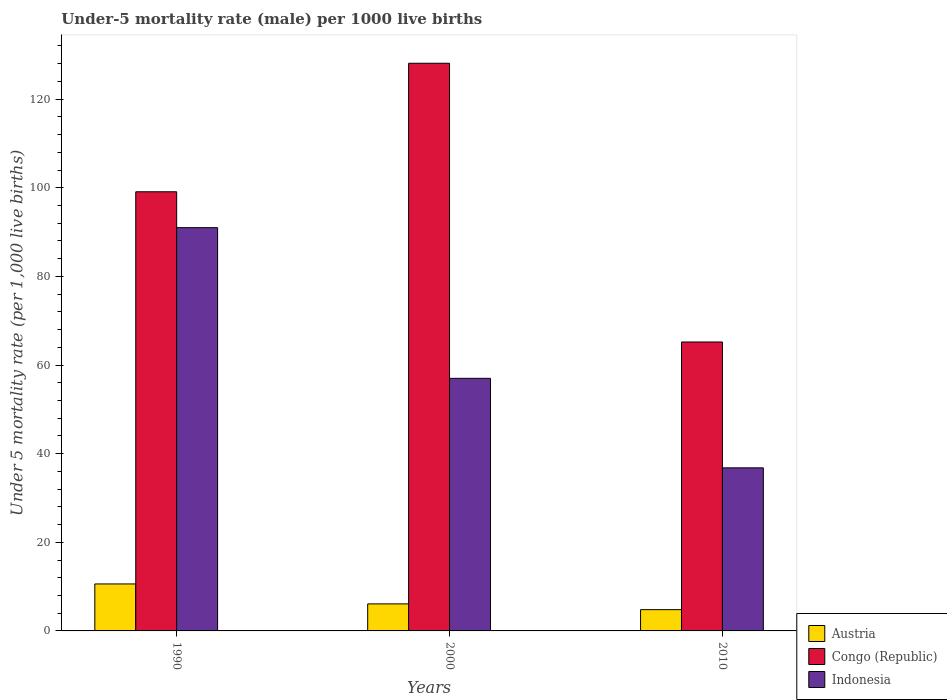How many different coloured bars are there?
Make the answer very short. 3. What is the label of the 3rd group of bars from the left?
Ensure brevity in your answer.  2010. In how many cases, is the number of bars for a given year not equal to the number of legend labels?
Provide a succinct answer. 0. What is the under-five mortality rate in Indonesia in 2010?
Give a very brief answer. 36.8. Across all years, what is the maximum under-five mortality rate in Indonesia?
Ensure brevity in your answer.  91. Across all years, what is the minimum under-five mortality rate in Indonesia?
Provide a succinct answer. 36.8. In which year was the under-five mortality rate in Congo (Republic) maximum?
Provide a short and direct response. 2000. In which year was the under-five mortality rate in Austria minimum?
Provide a succinct answer. 2010. What is the total under-five mortality rate in Congo (Republic) in the graph?
Make the answer very short. 292.4. What is the difference between the under-five mortality rate in Indonesia in 2000 and that in 2010?
Provide a short and direct response. 20.2. What is the difference between the under-five mortality rate in Congo (Republic) in 2010 and the under-five mortality rate in Indonesia in 1990?
Your response must be concise. -25.8. What is the average under-five mortality rate in Austria per year?
Offer a very short reply. 7.17. In the year 2010, what is the difference between the under-five mortality rate in Indonesia and under-five mortality rate in Congo (Republic)?
Give a very brief answer. -28.4. In how many years, is the under-five mortality rate in Indonesia greater than 80?
Ensure brevity in your answer.  1. What is the ratio of the under-five mortality rate in Congo (Republic) in 1990 to that in 2000?
Your response must be concise. 0.77. Is the under-five mortality rate in Austria in 1990 less than that in 2010?
Give a very brief answer. No. What is the difference between the highest and the second highest under-five mortality rate in Congo (Republic)?
Provide a succinct answer. 29. What is the difference between the highest and the lowest under-five mortality rate in Congo (Republic)?
Your response must be concise. 62.9. In how many years, is the under-five mortality rate in Indonesia greater than the average under-five mortality rate in Indonesia taken over all years?
Your response must be concise. 1. What does the 1st bar from the right in 2010 represents?
Provide a short and direct response. Indonesia. Are the values on the major ticks of Y-axis written in scientific E-notation?
Give a very brief answer. No. Does the graph contain grids?
Your answer should be compact. No. Where does the legend appear in the graph?
Provide a short and direct response. Bottom right. What is the title of the graph?
Ensure brevity in your answer.  Under-5 mortality rate (male) per 1000 live births. What is the label or title of the X-axis?
Give a very brief answer. Years. What is the label or title of the Y-axis?
Your answer should be compact. Under 5 mortality rate (per 1,0 live births). What is the Under 5 mortality rate (per 1,000 live births) in Austria in 1990?
Ensure brevity in your answer.  10.6. What is the Under 5 mortality rate (per 1,000 live births) of Congo (Republic) in 1990?
Your response must be concise. 99.1. What is the Under 5 mortality rate (per 1,000 live births) of Indonesia in 1990?
Your answer should be very brief. 91. What is the Under 5 mortality rate (per 1,000 live births) of Austria in 2000?
Provide a succinct answer. 6.1. What is the Under 5 mortality rate (per 1,000 live births) of Congo (Republic) in 2000?
Offer a very short reply. 128.1. What is the Under 5 mortality rate (per 1,000 live births) of Congo (Republic) in 2010?
Offer a terse response. 65.2. What is the Under 5 mortality rate (per 1,000 live births) in Indonesia in 2010?
Keep it short and to the point. 36.8. Across all years, what is the maximum Under 5 mortality rate (per 1,000 live births) in Austria?
Your answer should be compact. 10.6. Across all years, what is the maximum Under 5 mortality rate (per 1,000 live births) of Congo (Republic)?
Ensure brevity in your answer.  128.1. Across all years, what is the maximum Under 5 mortality rate (per 1,000 live births) in Indonesia?
Make the answer very short. 91. Across all years, what is the minimum Under 5 mortality rate (per 1,000 live births) in Austria?
Your answer should be very brief. 4.8. Across all years, what is the minimum Under 5 mortality rate (per 1,000 live births) of Congo (Republic)?
Provide a succinct answer. 65.2. Across all years, what is the minimum Under 5 mortality rate (per 1,000 live births) of Indonesia?
Provide a short and direct response. 36.8. What is the total Under 5 mortality rate (per 1,000 live births) in Congo (Republic) in the graph?
Offer a very short reply. 292.4. What is the total Under 5 mortality rate (per 1,000 live births) in Indonesia in the graph?
Ensure brevity in your answer.  184.8. What is the difference between the Under 5 mortality rate (per 1,000 live births) of Congo (Republic) in 1990 and that in 2010?
Give a very brief answer. 33.9. What is the difference between the Under 5 mortality rate (per 1,000 live births) of Indonesia in 1990 and that in 2010?
Ensure brevity in your answer.  54.2. What is the difference between the Under 5 mortality rate (per 1,000 live births) in Congo (Republic) in 2000 and that in 2010?
Ensure brevity in your answer.  62.9. What is the difference between the Under 5 mortality rate (per 1,000 live births) in Indonesia in 2000 and that in 2010?
Provide a succinct answer. 20.2. What is the difference between the Under 5 mortality rate (per 1,000 live births) of Austria in 1990 and the Under 5 mortality rate (per 1,000 live births) of Congo (Republic) in 2000?
Provide a short and direct response. -117.5. What is the difference between the Under 5 mortality rate (per 1,000 live births) of Austria in 1990 and the Under 5 mortality rate (per 1,000 live births) of Indonesia in 2000?
Keep it short and to the point. -46.4. What is the difference between the Under 5 mortality rate (per 1,000 live births) of Congo (Republic) in 1990 and the Under 5 mortality rate (per 1,000 live births) of Indonesia in 2000?
Give a very brief answer. 42.1. What is the difference between the Under 5 mortality rate (per 1,000 live births) in Austria in 1990 and the Under 5 mortality rate (per 1,000 live births) in Congo (Republic) in 2010?
Make the answer very short. -54.6. What is the difference between the Under 5 mortality rate (per 1,000 live births) in Austria in 1990 and the Under 5 mortality rate (per 1,000 live births) in Indonesia in 2010?
Give a very brief answer. -26.2. What is the difference between the Under 5 mortality rate (per 1,000 live births) in Congo (Republic) in 1990 and the Under 5 mortality rate (per 1,000 live births) in Indonesia in 2010?
Offer a terse response. 62.3. What is the difference between the Under 5 mortality rate (per 1,000 live births) of Austria in 2000 and the Under 5 mortality rate (per 1,000 live births) of Congo (Republic) in 2010?
Keep it short and to the point. -59.1. What is the difference between the Under 5 mortality rate (per 1,000 live births) in Austria in 2000 and the Under 5 mortality rate (per 1,000 live births) in Indonesia in 2010?
Keep it short and to the point. -30.7. What is the difference between the Under 5 mortality rate (per 1,000 live births) in Congo (Republic) in 2000 and the Under 5 mortality rate (per 1,000 live births) in Indonesia in 2010?
Offer a terse response. 91.3. What is the average Under 5 mortality rate (per 1,000 live births) of Austria per year?
Ensure brevity in your answer.  7.17. What is the average Under 5 mortality rate (per 1,000 live births) of Congo (Republic) per year?
Give a very brief answer. 97.47. What is the average Under 5 mortality rate (per 1,000 live births) of Indonesia per year?
Your answer should be compact. 61.6. In the year 1990, what is the difference between the Under 5 mortality rate (per 1,000 live births) of Austria and Under 5 mortality rate (per 1,000 live births) of Congo (Republic)?
Provide a short and direct response. -88.5. In the year 1990, what is the difference between the Under 5 mortality rate (per 1,000 live births) in Austria and Under 5 mortality rate (per 1,000 live births) in Indonesia?
Your response must be concise. -80.4. In the year 1990, what is the difference between the Under 5 mortality rate (per 1,000 live births) of Congo (Republic) and Under 5 mortality rate (per 1,000 live births) of Indonesia?
Ensure brevity in your answer.  8.1. In the year 2000, what is the difference between the Under 5 mortality rate (per 1,000 live births) of Austria and Under 5 mortality rate (per 1,000 live births) of Congo (Republic)?
Give a very brief answer. -122. In the year 2000, what is the difference between the Under 5 mortality rate (per 1,000 live births) in Austria and Under 5 mortality rate (per 1,000 live births) in Indonesia?
Your answer should be very brief. -50.9. In the year 2000, what is the difference between the Under 5 mortality rate (per 1,000 live births) in Congo (Republic) and Under 5 mortality rate (per 1,000 live births) in Indonesia?
Provide a short and direct response. 71.1. In the year 2010, what is the difference between the Under 5 mortality rate (per 1,000 live births) of Austria and Under 5 mortality rate (per 1,000 live births) of Congo (Republic)?
Make the answer very short. -60.4. In the year 2010, what is the difference between the Under 5 mortality rate (per 1,000 live births) in Austria and Under 5 mortality rate (per 1,000 live births) in Indonesia?
Keep it short and to the point. -32. In the year 2010, what is the difference between the Under 5 mortality rate (per 1,000 live births) of Congo (Republic) and Under 5 mortality rate (per 1,000 live births) of Indonesia?
Offer a terse response. 28.4. What is the ratio of the Under 5 mortality rate (per 1,000 live births) of Austria in 1990 to that in 2000?
Your response must be concise. 1.74. What is the ratio of the Under 5 mortality rate (per 1,000 live births) in Congo (Republic) in 1990 to that in 2000?
Offer a terse response. 0.77. What is the ratio of the Under 5 mortality rate (per 1,000 live births) of Indonesia in 1990 to that in 2000?
Keep it short and to the point. 1.6. What is the ratio of the Under 5 mortality rate (per 1,000 live births) in Austria in 1990 to that in 2010?
Offer a terse response. 2.21. What is the ratio of the Under 5 mortality rate (per 1,000 live births) of Congo (Republic) in 1990 to that in 2010?
Your response must be concise. 1.52. What is the ratio of the Under 5 mortality rate (per 1,000 live births) in Indonesia in 1990 to that in 2010?
Ensure brevity in your answer.  2.47. What is the ratio of the Under 5 mortality rate (per 1,000 live births) of Austria in 2000 to that in 2010?
Your response must be concise. 1.27. What is the ratio of the Under 5 mortality rate (per 1,000 live births) in Congo (Republic) in 2000 to that in 2010?
Ensure brevity in your answer.  1.96. What is the ratio of the Under 5 mortality rate (per 1,000 live births) in Indonesia in 2000 to that in 2010?
Provide a short and direct response. 1.55. What is the difference between the highest and the lowest Under 5 mortality rate (per 1,000 live births) of Congo (Republic)?
Ensure brevity in your answer.  62.9. What is the difference between the highest and the lowest Under 5 mortality rate (per 1,000 live births) in Indonesia?
Your response must be concise. 54.2. 